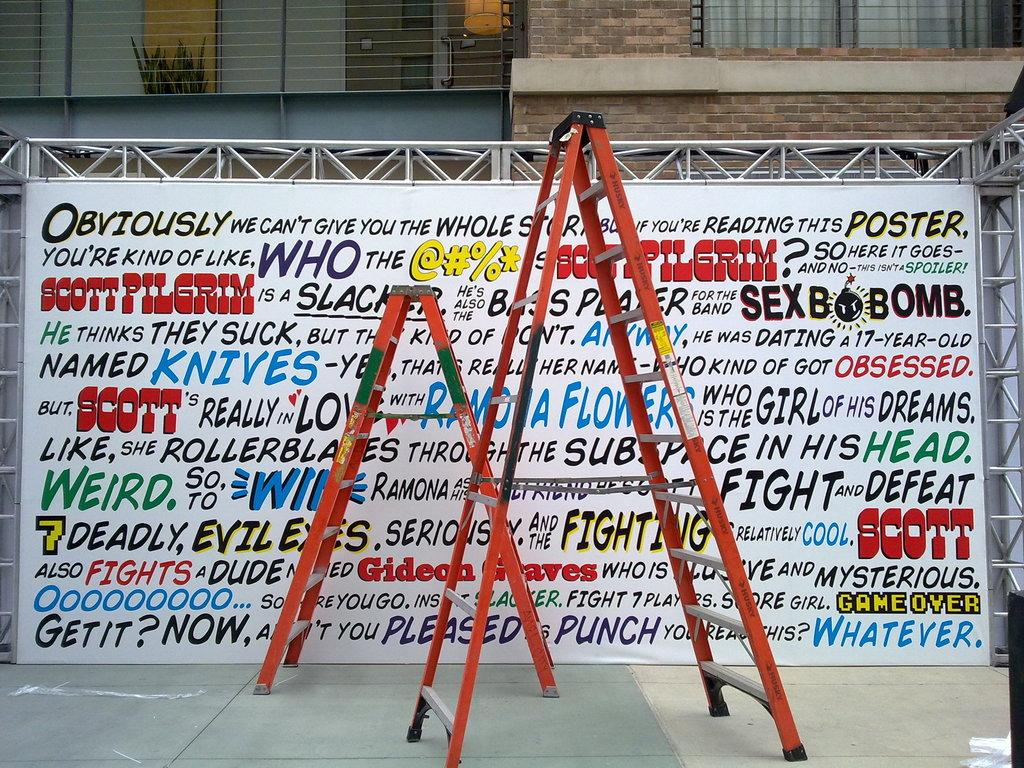Provide a one-sentence caption for the provided image. An art display showing many different kinds of texts and fonts about Scott Pilgrim. 